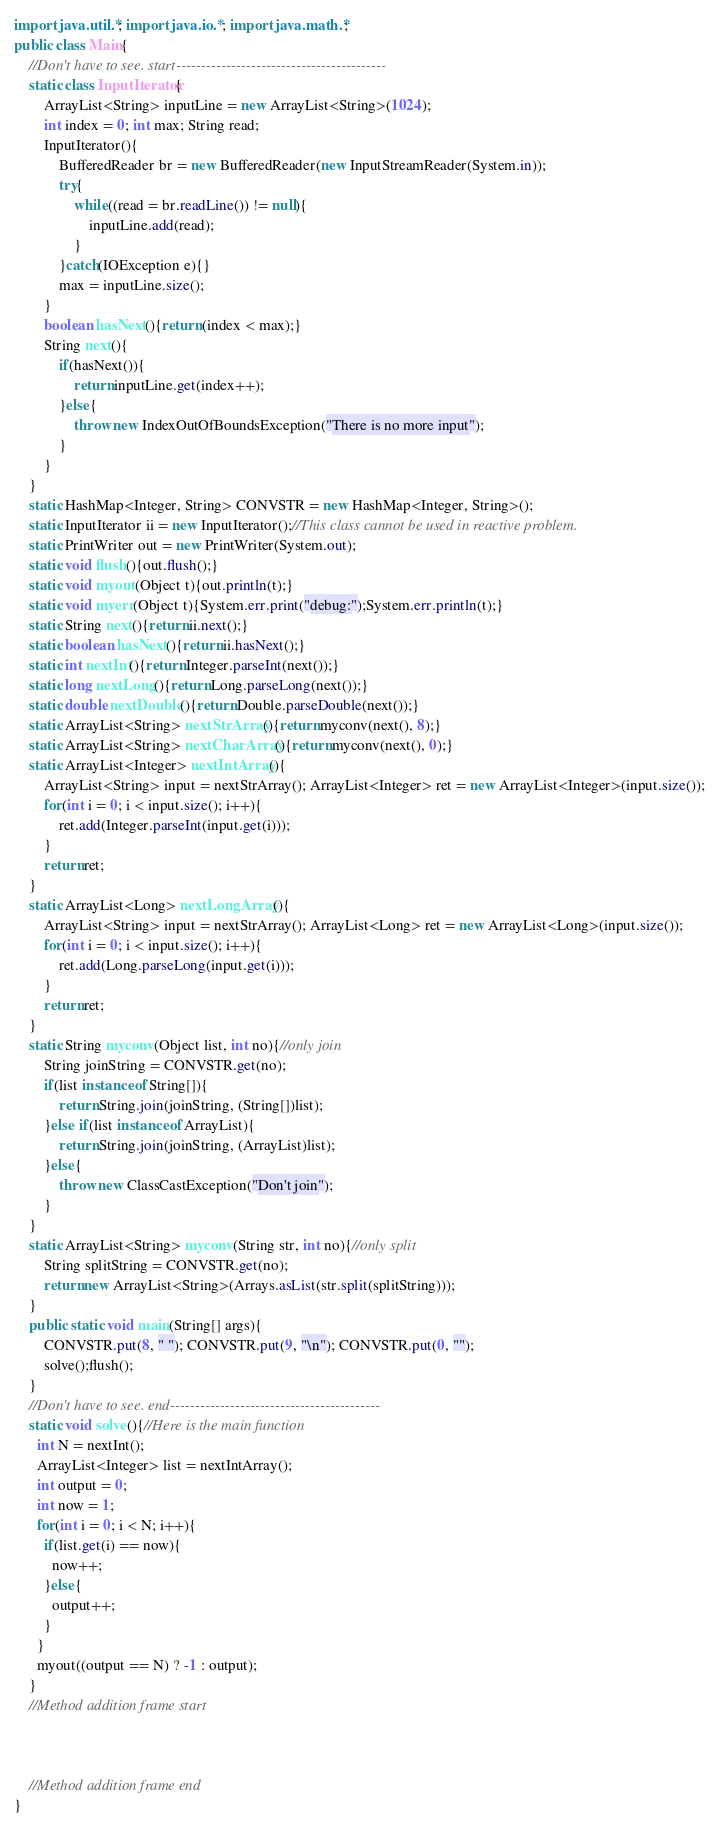Convert code to text. <code><loc_0><loc_0><loc_500><loc_500><_Java_>import java.util.*; import java.io.*; import java.math.*;
public class Main{
	//Don't have to see. start------------------------------------------
	static class InputIterator{
		ArrayList<String> inputLine = new ArrayList<String>(1024);
		int index = 0; int max; String read;
		InputIterator(){
			BufferedReader br = new BufferedReader(new InputStreamReader(System.in));
			try{
				while((read = br.readLine()) != null){
					inputLine.add(read);
				}
			}catch(IOException e){}
			max = inputLine.size();
		}
		boolean hasNext(){return (index < max);}
		String next(){
			if(hasNext()){
				return inputLine.get(index++);
			}else{
				throw new IndexOutOfBoundsException("There is no more input");
			}
		}
	}
	static HashMap<Integer, String> CONVSTR = new HashMap<Integer, String>();
	static InputIterator ii = new InputIterator();//This class cannot be used in reactive problem.
	static PrintWriter out = new PrintWriter(System.out);
	static void flush(){out.flush();}
	static void myout(Object t){out.println(t);}
	static void myerr(Object t){System.err.print("debug:");System.err.println(t);}
	static String next(){return ii.next();}
	static boolean hasNext(){return ii.hasNext();}
	static int nextInt(){return Integer.parseInt(next());}
	static long nextLong(){return Long.parseLong(next());}
	static double nextDouble(){return Double.parseDouble(next());}
	static ArrayList<String> nextStrArray(){return myconv(next(), 8);}
	static ArrayList<String> nextCharArray(){return myconv(next(), 0);}
	static ArrayList<Integer> nextIntArray(){
		ArrayList<String> input = nextStrArray(); ArrayList<Integer> ret = new ArrayList<Integer>(input.size());
		for(int i = 0; i < input.size(); i++){
			ret.add(Integer.parseInt(input.get(i)));
		}
		return ret;
	}
	static ArrayList<Long> nextLongArray(){
		ArrayList<String> input = nextStrArray(); ArrayList<Long> ret = new ArrayList<Long>(input.size());
		for(int i = 0; i < input.size(); i++){
			ret.add(Long.parseLong(input.get(i)));
		}
		return ret;
	}
	static String myconv(Object list, int no){//only join
		String joinString = CONVSTR.get(no);
		if(list instanceof String[]){
			return String.join(joinString, (String[])list);
		}else if(list instanceof ArrayList){
			return String.join(joinString, (ArrayList)list);
		}else{
			throw new ClassCastException("Don't join");
		}
	}
	static ArrayList<String> myconv(String str, int no){//only split
		String splitString = CONVSTR.get(no);
		return new ArrayList<String>(Arrays.asList(str.split(splitString)));
	}
	public static void main(String[] args){
		CONVSTR.put(8, " "); CONVSTR.put(9, "\n"); CONVSTR.put(0, "");
		solve();flush();
	}
	//Don't have to see. end------------------------------------------
	static void solve(){//Here is the main function
      int N = nextInt();
      ArrayList<Integer> list = nextIntArray();
      int output = 0;
      int now = 1;
      for(int i = 0; i < N; i++){
        if(list.get(i) == now){
          now++;
        }else{
          output++;
        }
      }
      myout((output == N) ? -1 : output);
	}
	//Method addition frame start



	//Method addition frame end
}
</code> 